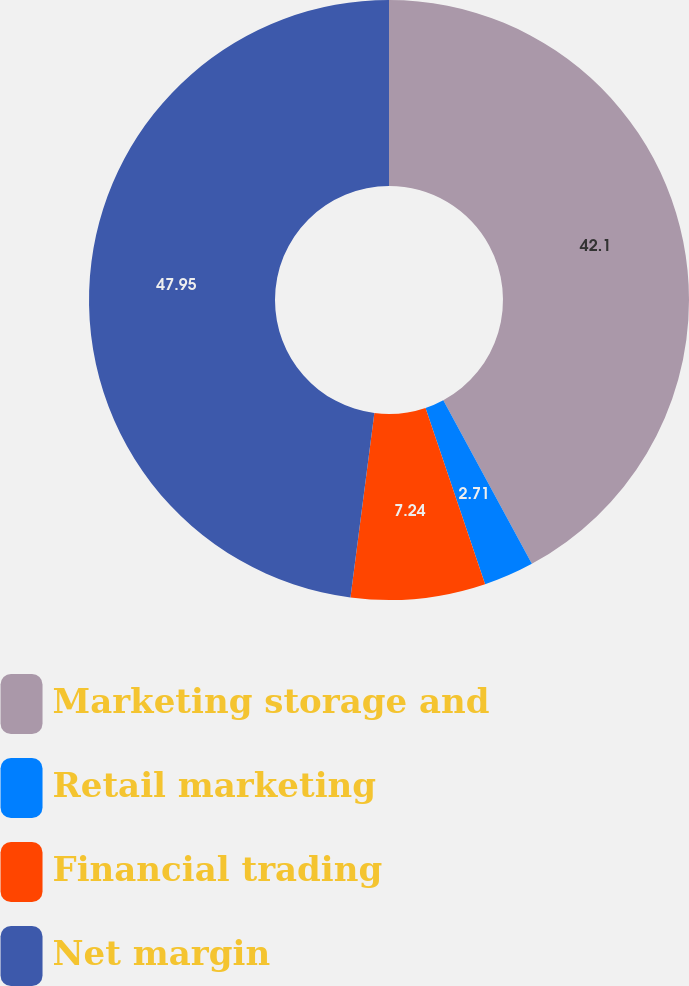<chart> <loc_0><loc_0><loc_500><loc_500><pie_chart><fcel>Marketing storage and<fcel>Retail marketing<fcel>Financial trading<fcel>Net margin<nl><fcel>42.1%<fcel>2.71%<fcel>7.24%<fcel>47.95%<nl></chart> 